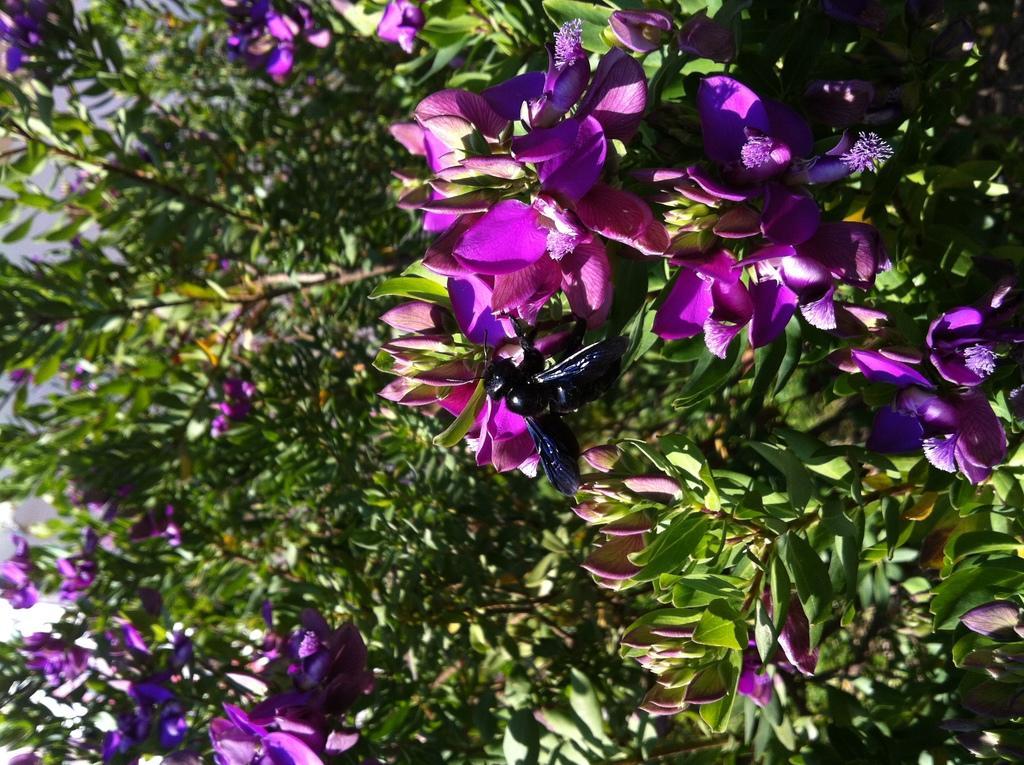Please provide a concise description of this image. In this image we can see fly on the flower. In the background we can see trees. 